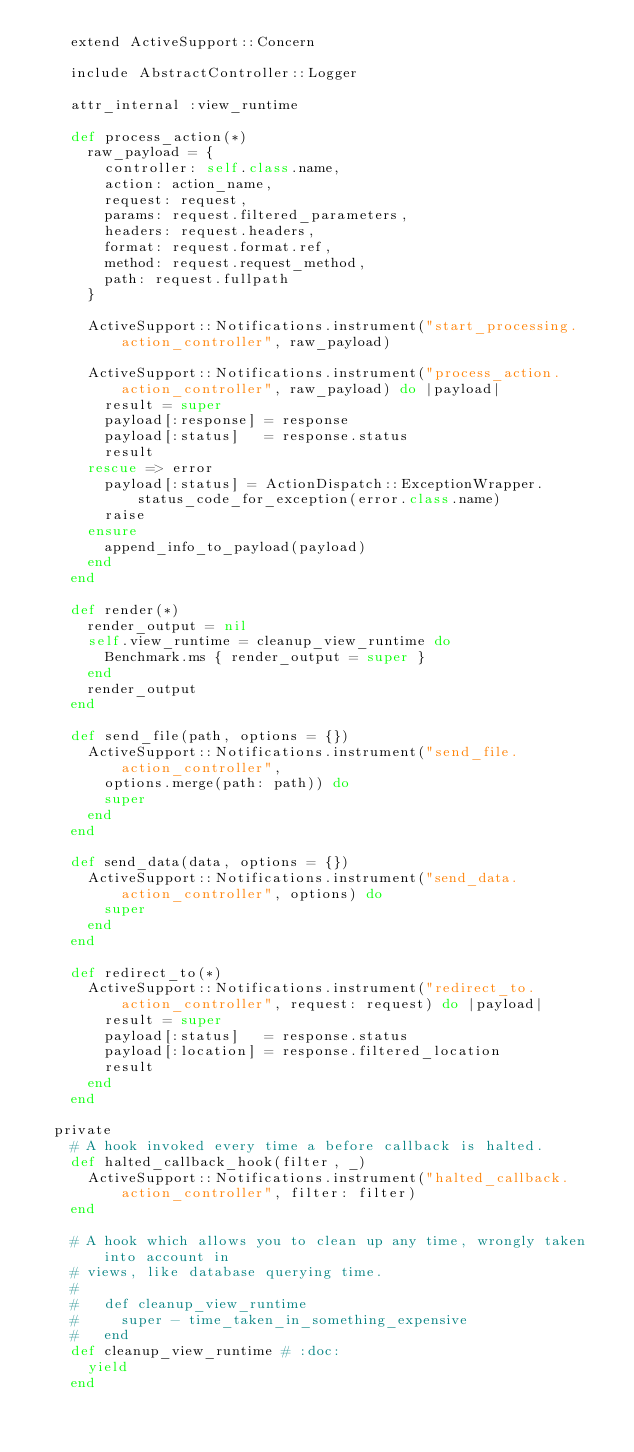<code> <loc_0><loc_0><loc_500><loc_500><_Ruby_>    extend ActiveSupport::Concern

    include AbstractController::Logger

    attr_internal :view_runtime

    def process_action(*)
      raw_payload = {
        controller: self.class.name,
        action: action_name,
        request: request,
        params: request.filtered_parameters,
        headers: request.headers,
        format: request.format.ref,
        method: request.request_method,
        path: request.fullpath
      }

      ActiveSupport::Notifications.instrument("start_processing.action_controller", raw_payload)

      ActiveSupport::Notifications.instrument("process_action.action_controller", raw_payload) do |payload|
        result = super
        payload[:response] = response
        payload[:status]   = response.status
        result
      rescue => error
        payload[:status] = ActionDispatch::ExceptionWrapper.status_code_for_exception(error.class.name)
        raise
      ensure
        append_info_to_payload(payload)
      end
    end

    def render(*)
      render_output = nil
      self.view_runtime = cleanup_view_runtime do
        Benchmark.ms { render_output = super }
      end
      render_output
    end

    def send_file(path, options = {})
      ActiveSupport::Notifications.instrument("send_file.action_controller",
        options.merge(path: path)) do
        super
      end
    end

    def send_data(data, options = {})
      ActiveSupport::Notifications.instrument("send_data.action_controller", options) do
        super
      end
    end

    def redirect_to(*)
      ActiveSupport::Notifications.instrument("redirect_to.action_controller", request: request) do |payload|
        result = super
        payload[:status]   = response.status
        payload[:location] = response.filtered_location
        result
      end
    end

  private
    # A hook invoked every time a before callback is halted.
    def halted_callback_hook(filter, _)
      ActiveSupport::Notifications.instrument("halted_callback.action_controller", filter: filter)
    end

    # A hook which allows you to clean up any time, wrongly taken into account in
    # views, like database querying time.
    #
    #   def cleanup_view_runtime
    #     super - time_taken_in_something_expensive
    #   end
    def cleanup_view_runtime # :doc:
      yield
    end
</code> 